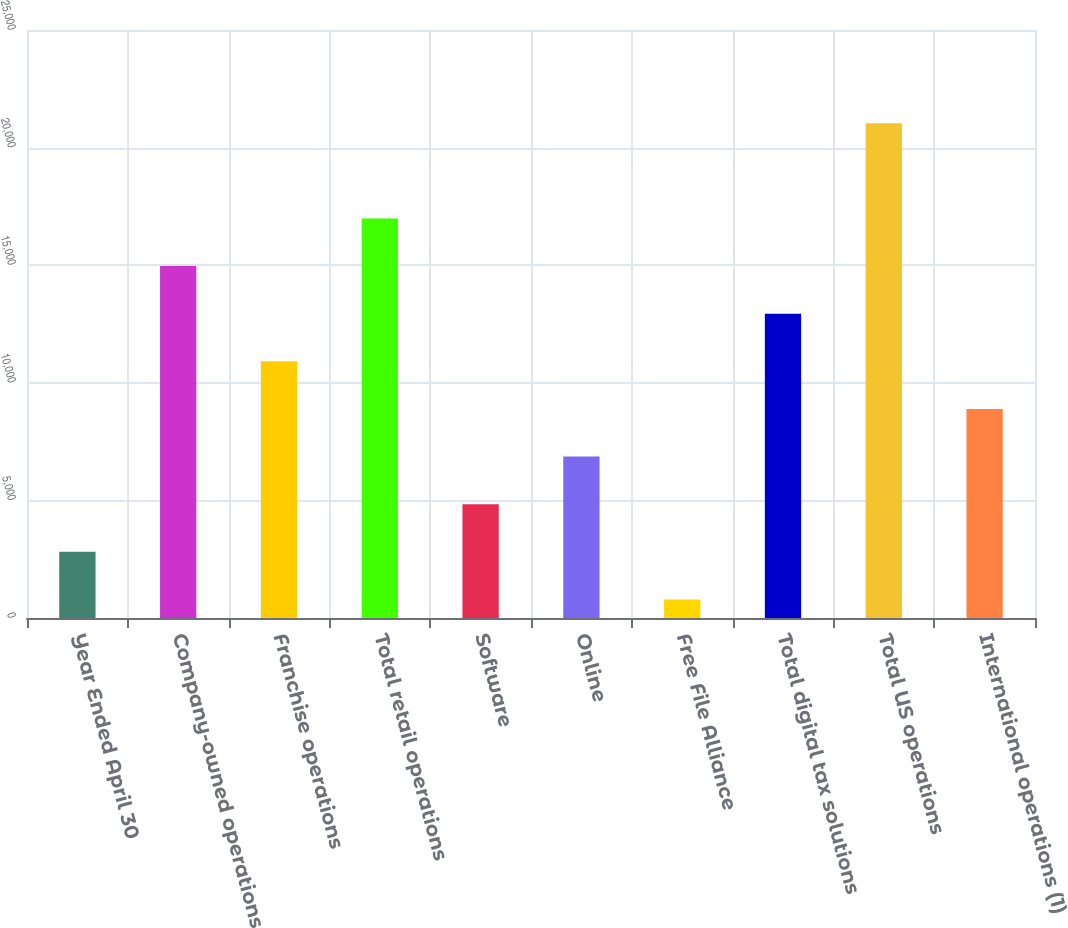<chart> <loc_0><loc_0><loc_500><loc_500><bar_chart><fcel>Year Ended April 30<fcel>Company-owned operations<fcel>Franchise operations<fcel>Total retail operations<fcel>Software<fcel>Online<fcel>Free File Alliance<fcel>Total digital tax solutions<fcel>Total US operations<fcel>International operations (1)<nl><fcel>2813.1<fcel>14963.7<fcel>10913.5<fcel>16988.8<fcel>4838.2<fcel>6863.3<fcel>788<fcel>12938.6<fcel>21039<fcel>8888.4<nl></chart> 